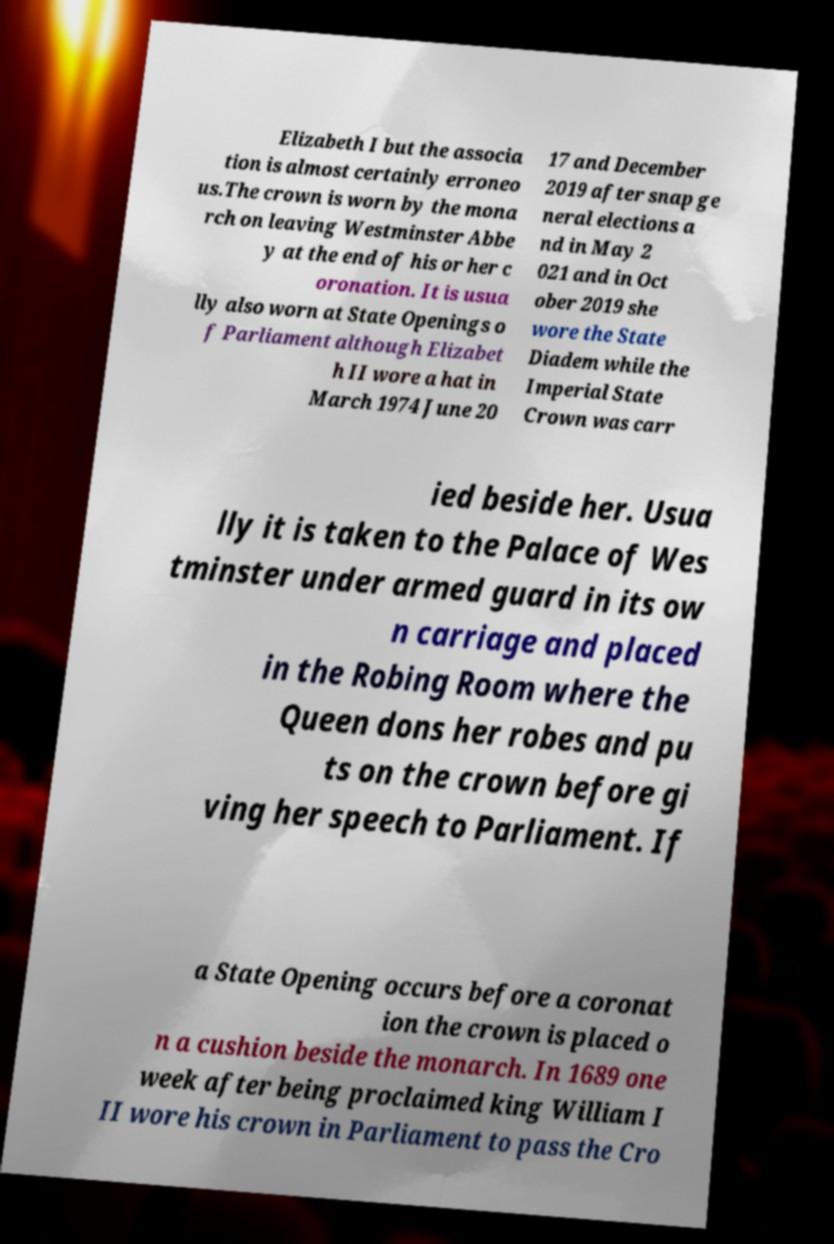I need the written content from this picture converted into text. Can you do that? Elizabeth I but the associa tion is almost certainly erroneo us.The crown is worn by the mona rch on leaving Westminster Abbe y at the end of his or her c oronation. It is usua lly also worn at State Openings o f Parliament although Elizabet h II wore a hat in March 1974 June 20 17 and December 2019 after snap ge neral elections a nd in May 2 021 and in Oct ober 2019 she wore the State Diadem while the Imperial State Crown was carr ied beside her. Usua lly it is taken to the Palace of Wes tminster under armed guard in its ow n carriage and placed in the Robing Room where the Queen dons her robes and pu ts on the crown before gi ving her speech to Parliament. If a State Opening occurs before a coronat ion the crown is placed o n a cushion beside the monarch. In 1689 one week after being proclaimed king William I II wore his crown in Parliament to pass the Cro 